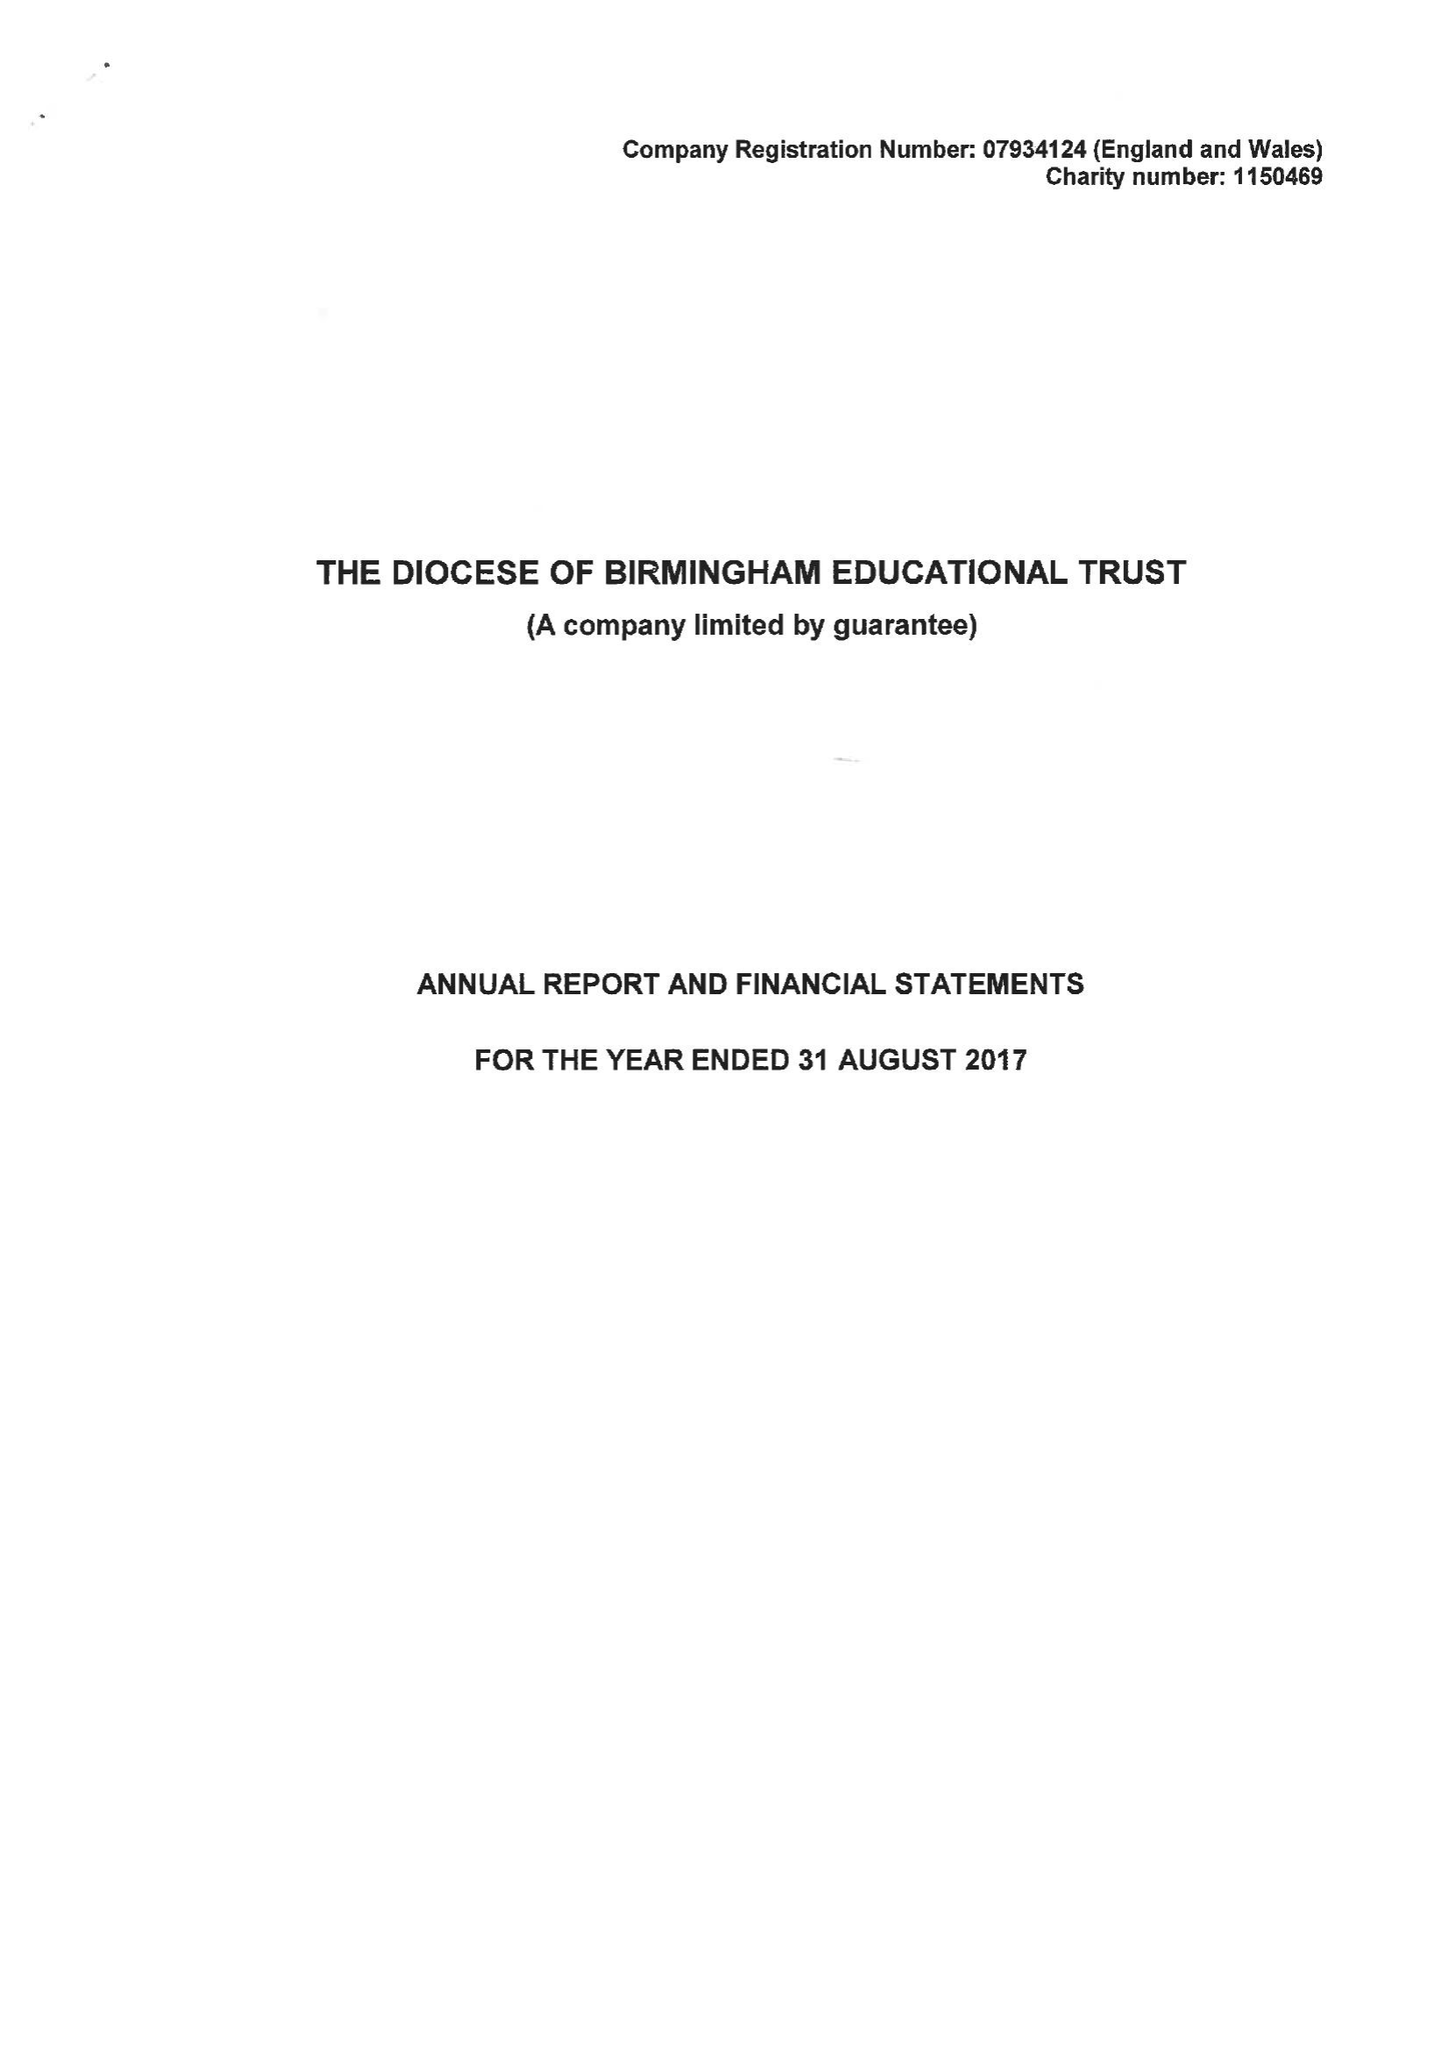What is the value for the address__post_town?
Answer the question using a single word or phrase. BIRMINGHAM 